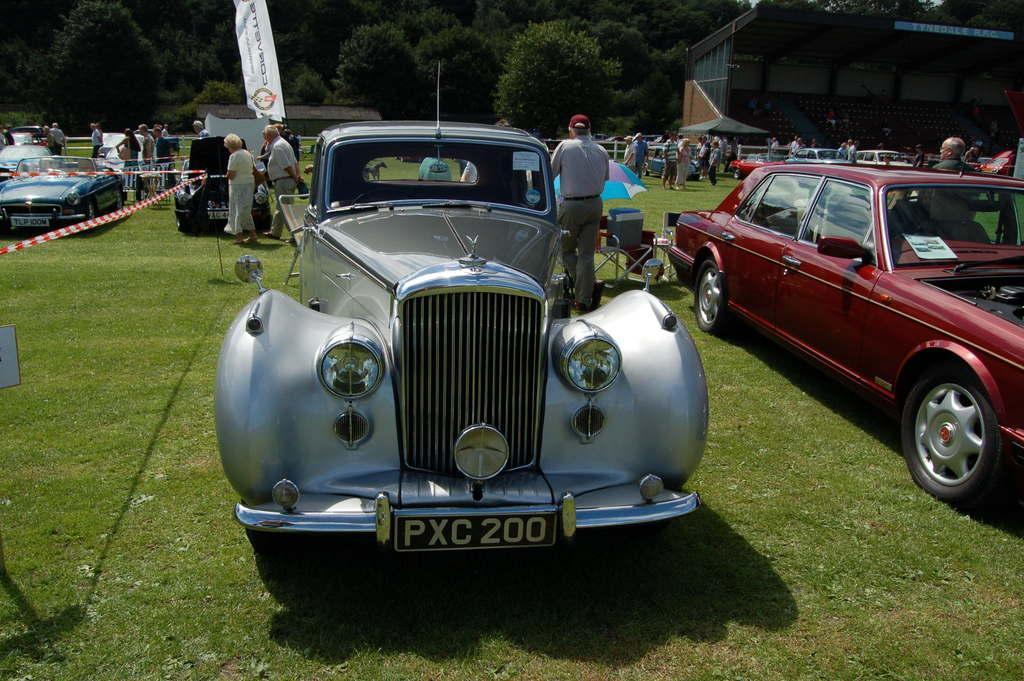Can you describe this image briefly? In this image there are cars on a ground, in the background there are people standing and there is fencing, trees and building. 